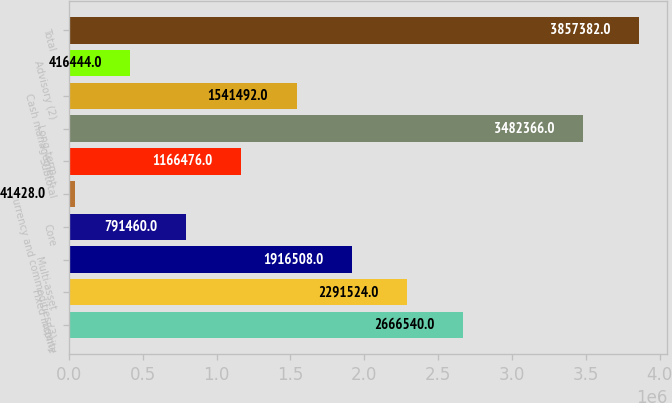Convert chart. <chart><loc_0><loc_0><loc_500><loc_500><bar_chart><fcel>Equity<fcel>Fixed income<fcel>Multi-asset<fcel>Core<fcel>Currency and commodities (3)<fcel>Subtotal<fcel>Long-term<fcel>Cash management<fcel>Advisory (2)<fcel>Total<nl><fcel>2.66654e+06<fcel>2.29152e+06<fcel>1.91651e+06<fcel>791460<fcel>41428<fcel>1.16648e+06<fcel>3.48237e+06<fcel>1.54149e+06<fcel>416444<fcel>3.85738e+06<nl></chart> 